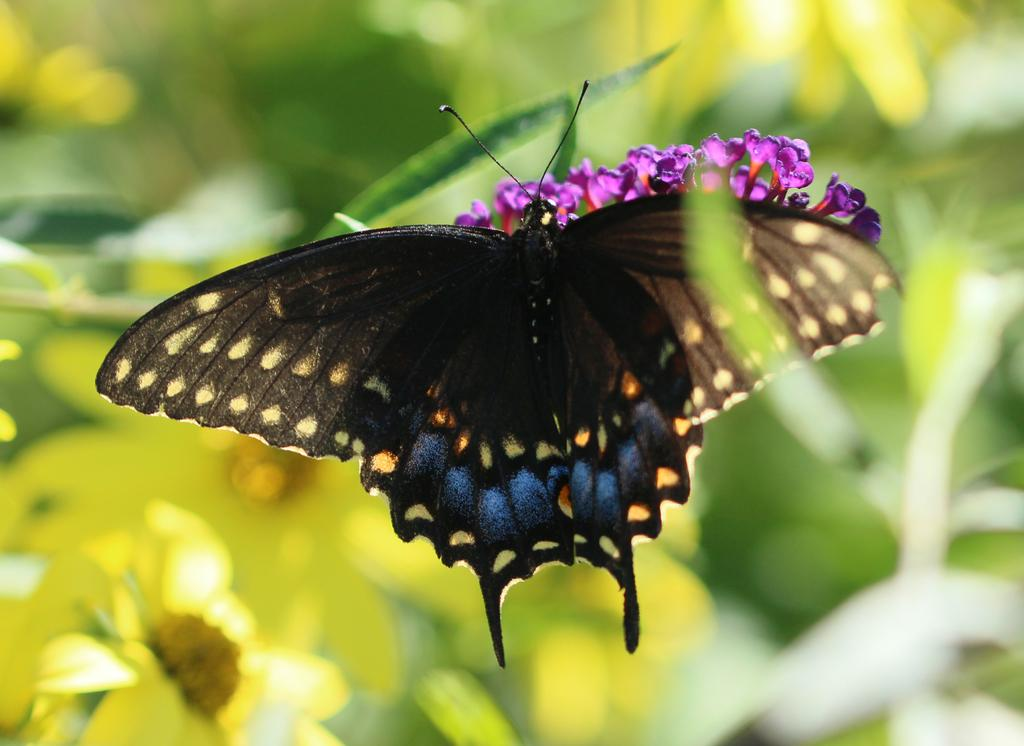What type of animal can be seen in the image? There is a butterfly in the image. What other living organisms are present in the image? There are flowers in the image. What can be seen in the background of the image? The background of the image includes blurred flowers and leaves. What type of mint can be seen growing in the image? There is no mint plant visible in the image; it only features a butterfly and flowers. How can the butterfly's wings be measured in the image? The image does not provide a scale or reference point for measuring the butterfly's wings. 